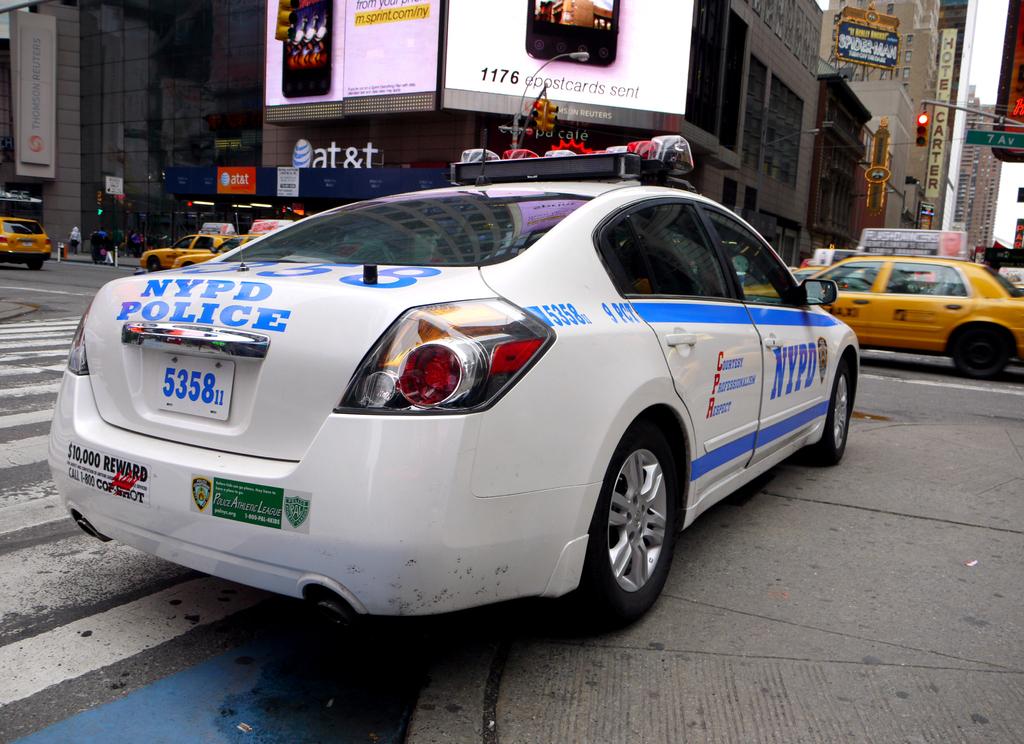What state do the police work for?
Your answer should be compact. New york. What unit number is the police car?
Make the answer very short. 5358. 